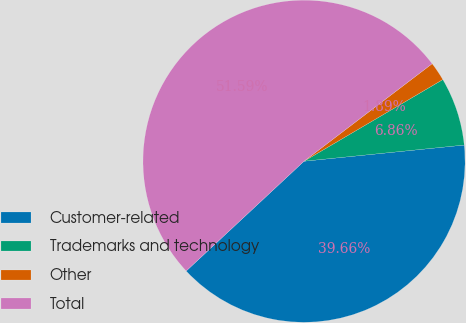Convert chart. <chart><loc_0><loc_0><loc_500><loc_500><pie_chart><fcel>Customer-related<fcel>Trademarks and technology<fcel>Other<fcel>Total<nl><fcel>39.66%<fcel>6.86%<fcel>1.89%<fcel>51.58%<nl></chart> 